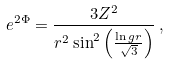Convert formula to latex. <formula><loc_0><loc_0><loc_500><loc_500>e ^ { 2 \Phi } = \frac { 3 Z ^ { 2 } } { r ^ { 2 } \sin ^ { 2 } \left ( \frac { \ln g r } { \sqrt { 3 } } \right ) } \, ,</formula> 